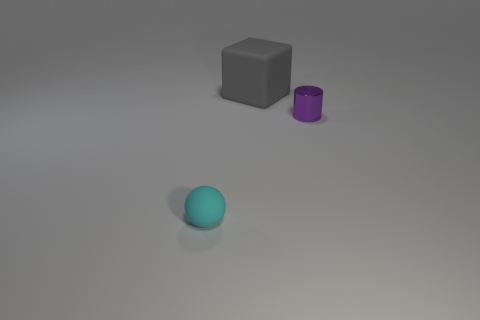Add 1 small cyan balls. How many objects exist? 4 Subtract all cubes. How many objects are left? 2 Subtract 0 purple blocks. How many objects are left? 3 Subtract all small purple things. Subtract all small rubber objects. How many objects are left? 1 Add 1 small cyan rubber objects. How many small cyan rubber objects are left? 2 Add 1 small purple metal cylinders. How many small purple metal cylinders exist? 2 